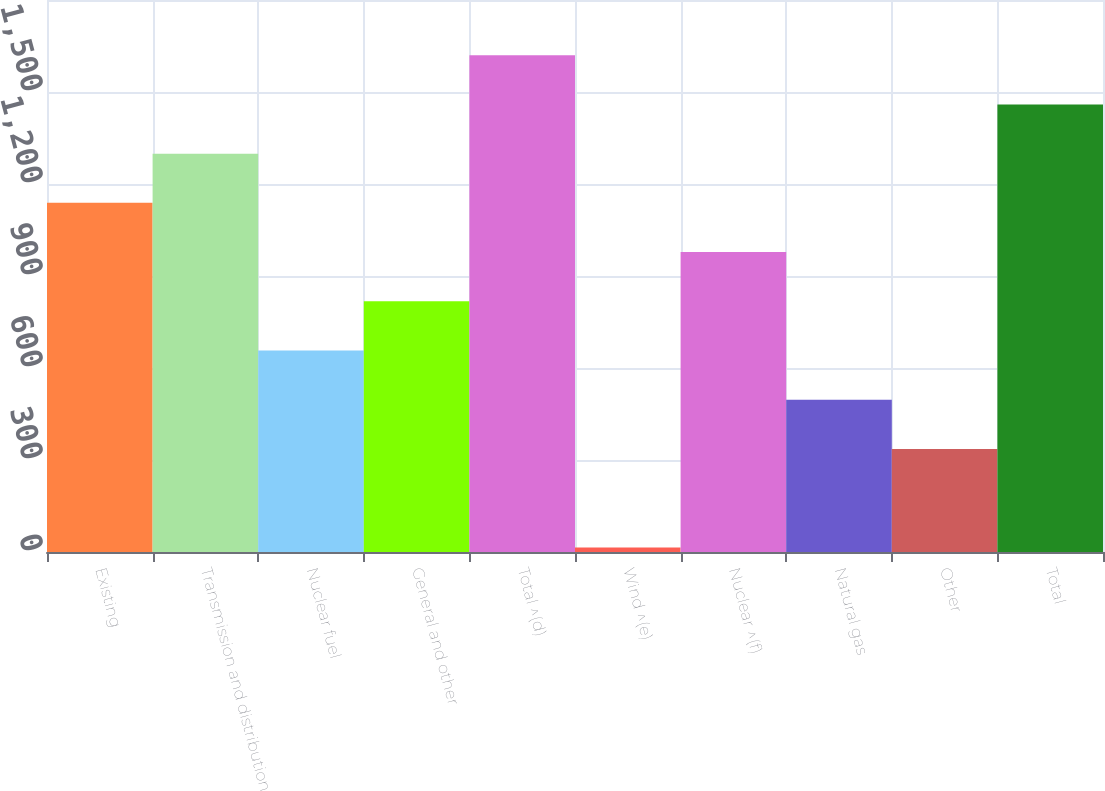Convert chart to OTSL. <chart><loc_0><loc_0><loc_500><loc_500><bar_chart><fcel>Existing<fcel>Transmission and distribution<fcel>Nuclear fuel<fcel>General and other<fcel>Total ^(d)<fcel>Wind ^(e)<fcel>Nuclear ^(f)<fcel>Natural gas<fcel>Other<fcel>Total<nl><fcel>1138.5<fcel>1299<fcel>657<fcel>817.5<fcel>1620<fcel>15<fcel>978<fcel>496.5<fcel>336<fcel>1459.5<nl></chart> 